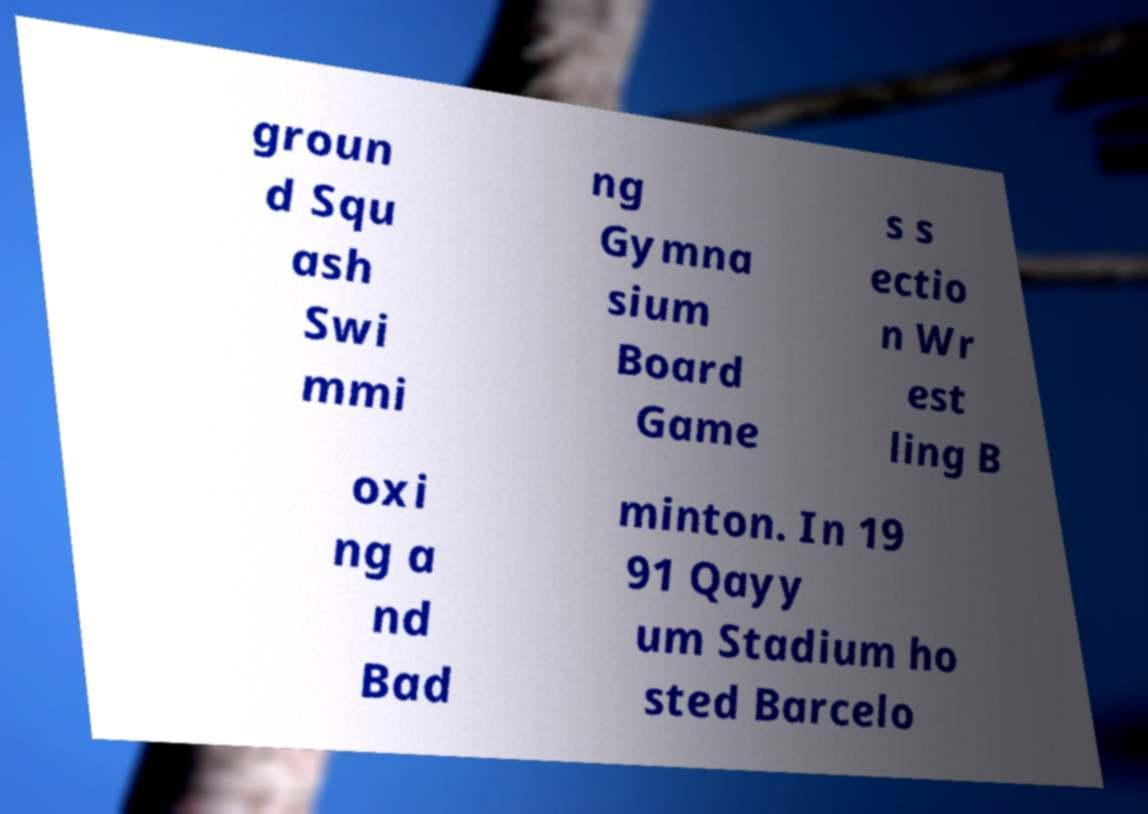Can you read and provide the text displayed in the image?This photo seems to have some interesting text. Can you extract and type it out for me? groun d Squ ash Swi mmi ng Gymna sium Board Game s s ectio n Wr est ling B oxi ng a nd Bad minton. In 19 91 Qayy um Stadium ho sted Barcelo 